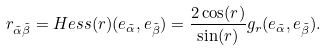<formula> <loc_0><loc_0><loc_500><loc_500>r _ { \tilde { \alpha } \tilde { \beta } } = H e s s ( r ) ( e _ { \tilde { \alpha } } , e _ { \tilde { \beta } } ) = \frac { 2 \cos ( r ) } { \sin ( r ) } g _ { r } ( e _ { \tilde { \alpha } } , e _ { \tilde { \beta } } ) .</formula> 